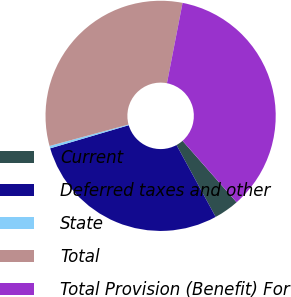<chart> <loc_0><loc_0><loc_500><loc_500><pie_chart><fcel>Current<fcel>Deferred taxes and other<fcel>State<fcel>Total<fcel>Total Provision (Benefit) For<nl><fcel>3.54%<fcel>28.38%<fcel>0.34%<fcel>32.27%<fcel>35.47%<nl></chart> 